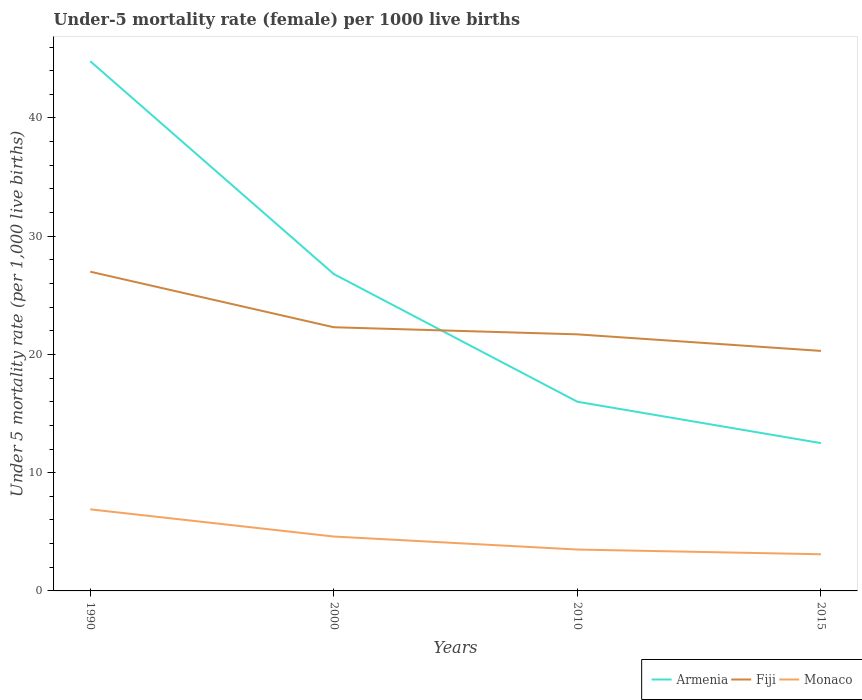Is the number of lines equal to the number of legend labels?
Your answer should be compact. Yes. Across all years, what is the maximum under-five mortality rate in Fiji?
Make the answer very short. 20.3. In which year was the under-five mortality rate in Monaco maximum?
Ensure brevity in your answer.  2015. What is the total under-five mortality rate in Armenia in the graph?
Give a very brief answer. 28.8. What is the difference between the highest and the second highest under-five mortality rate in Armenia?
Provide a succinct answer. 32.3. What is the difference between the highest and the lowest under-five mortality rate in Fiji?
Your answer should be compact. 1. Is the under-five mortality rate in Armenia strictly greater than the under-five mortality rate in Fiji over the years?
Offer a very short reply. No. How many lines are there?
Provide a short and direct response. 3. How many years are there in the graph?
Your answer should be very brief. 4. What is the difference between two consecutive major ticks on the Y-axis?
Your answer should be very brief. 10. How many legend labels are there?
Keep it short and to the point. 3. What is the title of the graph?
Your answer should be very brief. Under-5 mortality rate (female) per 1000 live births. Does "Slovenia" appear as one of the legend labels in the graph?
Give a very brief answer. No. What is the label or title of the X-axis?
Your answer should be compact. Years. What is the label or title of the Y-axis?
Ensure brevity in your answer.  Under 5 mortality rate (per 1,0 live births). What is the Under 5 mortality rate (per 1,000 live births) in Armenia in 1990?
Your answer should be compact. 44.8. What is the Under 5 mortality rate (per 1,000 live births) in Armenia in 2000?
Offer a terse response. 26.8. What is the Under 5 mortality rate (per 1,000 live births) in Fiji in 2000?
Your answer should be compact. 22.3. What is the Under 5 mortality rate (per 1,000 live births) of Monaco in 2000?
Provide a short and direct response. 4.6. What is the Under 5 mortality rate (per 1,000 live births) in Armenia in 2010?
Offer a very short reply. 16. What is the Under 5 mortality rate (per 1,000 live births) in Fiji in 2010?
Make the answer very short. 21.7. What is the Under 5 mortality rate (per 1,000 live births) of Fiji in 2015?
Provide a succinct answer. 20.3. Across all years, what is the maximum Under 5 mortality rate (per 1,000 live births) of Armenia?
Offer a very short reply. 44.8. Across all years, what is the minimum Under 5 mortality rate (per 1,000 live births) in Armenia?
Ensure brevity in your answer.  12.5. Across all years, what is the minimum Under 5 mortality rate (per 1,000 live births) of Fiji?
Provide a short and direct response. 20.3. What is the total Under 5 mortality rate (per 1,000 live births) in Armenia in the graph?
Provide a short and direct response. 100.1. What is the total Under 5 mortality rate (per 1,000 live births) in Fiji in the graph?
Give a very brief answer. 91.3. What is the total Under 5 mortality rate (per 1,000 live births) in Monaco in the graph?
Make the answer very short. 18.1. What is the difference between the Under 5 mortality rate (per 1,000 live births) in Monaco in 1990 and that in 2000?
Offer a terse response. 2.3. What is the difference between the Under 5 mortality rate (per 1,000 live births) of Armenia in 1990 and that in 2010?
Make the answer very short. 28.8. What is the difference between the Under 5 mortality rate (per 1,000 live births) in Monaco in 1990 and that in 2010?
Keep it short and to the point. 3.4. What is the difference between the Under 5 mortality rate (per 1,000 live births) of Armenia in 1990 and that in 2015?
Give a very brief answer. 32.3. What is the difference between the Under 5 mortality rate (per 1,000 live births) in Fiji in 2000 and that in 2010?
Provide a succinct answer. 0.6. What is the difference between the Under 5 mortality rate (per 1,000 live births) in Armenia in 2000 and that in 2015?
Your answer should be compact. 14.3. What is the difference between the Under 5 mortality rate (per 1,000 live births) of Fiji in 2000 and that in 2015?
Offer a terse response. 2. What is the difference between the Under 5 mortality rate (per 1,000 live births) of Fiji in 2010 and that in 2015?
Provide a short and direct response. 1.4. What is the difference between the Under 5 mortality rate (per 1,000 live births) of Armenia in 1990 and the Under 5 mortality rate (per 1,000 live births) of Monaco in 2000?
Offer a terse response. 40.2. What is the difference between the Under 5 mortality rate (per 1,000 live births) in Fiji in 1990 and the Under 5 mortality rate (per 1,000 live births) in Monaco in 2000?
Your response must be concise. 22.4. What is the difference between the Under 5 mortality rate (per 1,000 live births) in Armenia in 1990 and the Under 5 mortality rate (per 1,000 live births) in Fiji in 2010?
Your answer should be compact. 23.1. What is the difference between the Under 5 mortality rate (per 1,000 live births) in Armenia in 1990 and the Under 5 mortality rate (per 1,000 live births) in Monaco in 2010?
Your response must be concise. 41.3. What is the difference between the Under 5 mortality rate (per 1,000 live births) in Armenia in 1990 and the Under 5 mortality rate (per 1,000 live births) in Monaco in 2015?
Make the answer very short. 41.7. What is the difference between the Under 5 mortality rate (per 1,000 live births) in Fiji in 1990 and the Under 5 mortality rate (per 1,000 live births) in Monaco in 2015?
Offer a terse response. 23.9. What is the difference between the Under 5 mortality rate (per 1,000 live births) of Armenia in 2000 and the Under 5 mortality rate (per 1,000 live births) of Monaco in 2010?
Provide a short and direct response. 23.3. What is the difference between the Under 5 mortality rate (per 1,000 live births) of Armenia in 2000 and the Under 5 mortality rate (per 1,000 live births) of Fiji in 2015?
Give a very brief answer. 6.5. What is the difference between the Under 5 mortality rate (per 1,000 live births) of Armenia in 2000 and the Under 5 mortality rate (per 1,000 live births) of Monaco in 2015?
Ensure brevity in your answer.  23.7. What is the difference between the Under 5 mortality rate (per 1,000 live births) in Armenia in 2010 and the Under 5 mortality rate (per 1,000 live births) in Fiji in 2015?
Keep it short and to the point. -4.3. What is the difference between the Under 5 mortality rate (per 1,000 live births) in Fiji in 2010 and the Under 5 mortality rate (per 1,000 live births) in Monaco in 2015?
Offer a very short reply. 18.6. What is the average Under 5 mortality rate (per 1,000 live births) in Armenia per year?
Your answer should be very brief. 25.02. What is the average Under 5 mortality rate (per 1,000 live births) of Fiji per year?
Make the answer very short. 22.82. What is the average Under 5 mortality rate (per 1,000 live births) in Monaco per year?
Offer a very short reply. 4.53. In the year 1990, what is the difference between the Under 5 mortality rate (per 1,000 live births) in Armenia and Under 5 mortality rate (per 1,000 live births) in Monaco?
Your answer should be compact. 37.9. In the year 1990, what is the difference between the Under 5 mortality rate (per 1,000 live births) in Fiji and Under 5 mortality rate (per 1,000 live births) in Monaco?
Offer a very short reply. 20.1. In the year 2000, what is the difference between the Under 5 mortality rate (per 1,000 live births) of Armenia and Under 5 mortality rate (per 1,000 live births) of Monaco?
Your response must be concise. 22.2. In the year 2000, what is the difference between the Under 5 mortality rate (per 1,000 live births) in Fiji and Under 5 mortality rate (per 1,000 live births) in Monaco?
Your answer should be compact. 17.7. In the year 2010, what is the difference between the Under 5 mortality rate (per 1,000 live births) of Armenia and Under 5 mortality rate (per 1,000 live births) of Fiji?
Keep it short and to the point. -5.7. In the year 2010, what is the difference between the Under 5 mortality rate (per 1,000 live births) of Fiji and Under 5 mortality rate (per 1,000 live births) of Monaco?
Your answer should be compact. 18.2. In the year 2015, what is the difference between the Under 5 mortality rate (per 1,000 live births) of Armenia and Under 5 mortality rate (per 1,000 live births) of Fiji?
Your response must be concise. -7.8. What is the ratio of the Under 5 mortality rate (per 1,000 live births) of Armenia in 1990 to that in 2000?
Your response must be concise. 1.67. What is the ratio of the Under 5 mortality rate (per 1,000 live births) in Fiji in 1990 to that in 2000?
Keep it short and to the point. 1.21. What is the ratio of the Under 5 mortality rate (per 1,000 live births) in Monaco in 1990 to that in 2000?
Your answer should be very brief. 1.5. What is the ratio of the Under 5 mortality rate (per 1,000 live births) of Armenia in 1990 to that in 2010?
Offer a terse response. 2.8. What is the ratio of the Under 5 mortality rate (per 1,000 live births) in Fiji in 1990 to that in 2010?
Make the answer very short. 1.24. What is the ratio of the Under 5 mortality rate (per 1,000 live births) in Monaco in 1990 to that in 2010?
Provide a succinct answer. 1.97. What is the ratio of the Under 5 mortality rate (per 1,000 live births) in Armenia in 1990 to that in 2015?
Offer a terse response. 3.58. What is the ratio of the Under 5 mortality rate (per 1,000 live births) of Fiji in 1990 to that in 2015?
Keep it short and to the point. 1.33. What is the ratio of the Under 5 mortality rate (per 1,000 live births) in Monaco in 1990 to that in 2015?
Offer a very short reply. 2.23. What is the ratio of the Under 5 mortality rate (per 1,000 live births) in Armenia in 2000 to that in 2010?
Offer a very short reply. 1.68. What is the ratio of the Under 5 mortality rate (per 1,000 live births) in Fiji in 2000 to that in 2010?
Provide a succinct answer. 1.03. What is the ratio of the Under 5 mortality rate (per 1,000 live births) in Monaco in 2000 to that in 2010?
Ensure brevity in your answer.  1.31. What is the ratio of the Under 5 mortality rate (per 1,000 live births) in Armenia in 2000 to that in 2015?
Provide a short and direct response. 2.14. What is the ratio of the Under 5 mortality rate (per 1,000 live births) of Fiji in 2000 to that in 2015?
Provide a short and direct response. 1.1. What is the ratio of the Under 5 mortality rate (per 1,000 live births) of Monaco in 2000 to that in 2015?
Provide a succinct answer. 1.48. What is the ratio of the Under 5 mortality rate (per 1,000 live births) of Armenia in 2010 to that in 2015?
Make the answer very short. 1.28. What is the ratio of the Under 5 mortality rate (per 1,000 live births) of Fiji in 2010 to that in 2015?
Make the answer very short. 1.07. What is the ratio of the Under 5 mortality rate (per 1,000 live births) of Monaco in 2010 to that in 2015?
Give a very brief answer. 1.13. What is the difference between the highest and the lowest Under 5 mortality rate (per 1,000 live births) in Armenia?
Your answer should be very brief. 32.3. What is the difference between the highest and the lowest Under 5 mortality rate (per 1,000 live births) of Monaco?
Provide a short and direct response. 3.8. 